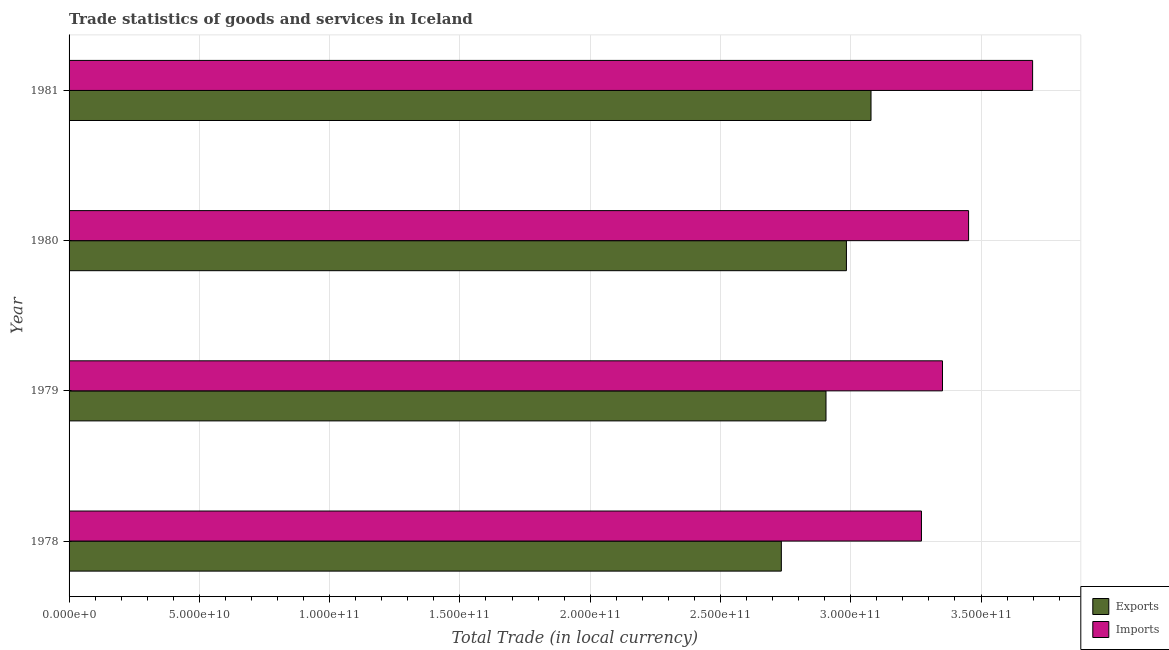How many different coloured bars are there?
Provide a short and direct response. 2. Are the number of bars per tick equal to the number of legend labels?
Provide a short and direct response. Yes. Are the number of bars on each tick of the Y-axis equal?
Keep it short and to the point. Yes. How many bars are there on the 4th tick from the top?
Give a very brief answer. 2. What is the label of the 4th group of bars from the top?
Your answer should be very brief. 1978. In how many cases, is the number of bars for a given year not equal to the number of legend labels?
Offer a very short reply. 0. What is the export of goods and services in 1981?
Provide a short and direct response. 3.08e+11. Across all years, what is the maximum export of goods and services?
Your response must be concise. 3.08e+11. Across all years, what is the minimum imports of goods and services?
Your answer should be compact. 3.27e+11. In which year was the imports of goods and services minimum?
Ensure brevity in your answer.  1978. What is the total imports of goods and services in the graph?
Offer a very short reply. 1.38e+12. What is the difference between the export of goods and services in 1978 and that in 1981?
Keep it short and to the point. -3.44e+1. What is the difference between the export of goods and services in 1978 and the imports of goods and services in 1979?
Your response must be concise. -6.18e+1. What is the average export of goods and services per year?
Keep it short and to the point. 2.92e+11. In the year 1980, what is the difference between the imports of goods and services and export of goods and services?
Your answer should be compact. 4.69e+1. In how many years, is the export of goods and services greater than 100000000000 LCU?
Ensure brevity in your answer.  4. What is the ratio of the export of goods and services in 1978 to that in 1979?
Make the answer very short. 0.94. Is the difference between the export of goods and services in 1979 and 1980 greater than the difference between the imports of goods and services in 1979 and 1980?
Offer a very short reply. Yes. What is the difference between the highest and the second highest imports of goods and services?
Provide a succinct answer. 2.46e+1. What is the difference between the highest and the lowest imports of goods and services?
Give a very brief answer. 4.27e+1. Is the sum of the export of goods and services in 1979 and 1980 greater than the maximum imports of goods and services across all years?
Ensure brevity in your answer.  Yes. What does the 2nd bar from the top in 1980 represents?
Your answer should be compact. Exports. What does the 2nd bar from the bottom in 1978 represents?
Your response must be concise. Imports. How many bars are there?
Your answer should be very brief. 8. Are all the bars in the graph horizontal?
Your response must be concise. Yes. How many years are there in the graph?
Offer a terse response. 4. Are the values on the major ticks of X-axis written in scientific E-notation?
Provide a succinct answer. Yes. Does the graph contain any zero values?
Make the answer very short. No. Does the graph contain grids?
Make the answer very short. Yes. Where does the legend appear in the graph?
Your answer should be very brief. Bottom right. How many legend labels are there?
Provide a succinct answer. 2. How are the legend labels stacked?
Make the answer very short. Vertical. What is the title of the graph?
Your answer should be very brief. Trade statistics of goods and services in Iceland. Does "Travel Items" appear as one of the legend labels in the graph?
Offer a terse response. No. What is the label or title of the X-axis?
Provide a succinct answer. Total Trade (in local currency). What is the Total Trade (in local currency) of Exports in 1978?
Make the answer very short. 2.73e+11. What is the Total Trade (in local currency) of Imports in 1978?
Your response must be concise. 3.27e+11. What is the Total Trade (in local currency) of Exports in 1979?
Provide a short and direct response. 2.91e+11. What is the Total Trade (in local currency) in Imports in 1979?
Ensure brevity in your answer.  3.35e+11. What is the Total Trade (in local currency) in Exports in 1980?
Keep it short and to the point. 2.98e+11. What is the Total Trade (in local currency) in Imports in 1980?
Offer a very short reply. 3.45e+11. What is the Total Trade (in local currency) of Exports in 1981?
Give a very brief answer. 3.08e+11. What is the Total Trade (in local currency) of Imports in 1981?
Provide a succinct answer. 3.70e+11. Across all years, what is the maximum Total Trade (in local currency) in Exports?
Offer a terse response. 3.08e+11. Across all years, what is the maximum Total Trade (in local currency) of Imports?
Offer a very short reply. 3.70e+11. Across all years, what is the minimum Total Trade (in local currency) of Exports?
Offer a terse response. 2.73e+11. Across all years, what is the minimum Total Trade (in local currency) in Imports?
Offer a terse response. 3.27e+11. What is the total Total Trade (in local currency) of Exports in the graph?
Your answer should be compact. 1.17e+12. What is the total Total Trade (in local currency) of Imports in the graph?
Your answer should be compact. 1.38e+12. What is the difference between the Total Trade (in local currency) of Exports in 1978 and that in 1979?
Give a very brief answer. -1.71e+1. What is the difference between the Total Trade (in local currency) of Imports in 1978 and that in 1979?
Give a very brief answer. -8.07e+09. What is the difference between the Total Trade (in local currency) in Exports in 1978 and that in 1980?
Offer a very short reply. -2.50e+1. What is the difference between the Total Trade (in local currency) in Imports in 1978 and that in 1980?
Provide a succinct answer. -1.81e+1. What is the difference between the Total Trade (in local currency) in Exports in 1978 and that in 1981?
Your response must be concise. -3.44e+1. What is the difference between the Total Trade (in local currency) in Imports in 1978 and that in 1981?
Keep it short and to the point. -4.27e+1. What is the difference between the Total Trade (in local currency) of Exports in 1979 and that in 1980?
Provide a succinct answer. -7.84e+09. What is the difference between the Total Trade (in local currency) in Imports in 1979 and that in 1980?
Offer a terse response. -1.00e+1. What is the difference between the Total Trade (in local currency) in Exports in 1979 and that in 1981?
Your response must be concise. -1.73e+1. What is the difference between the Total Trade (in local currency) in Imports in 1979 and that in 1981?
Your response must be concise. -3.46e+1. What is the difference between the Total Trade (in local currency) in Exports in 1980 and that in 1981?
Make the answer very short. -9.44e+09. What is the difference between the Total Trade (in local currency) of Imports in 1980 and that in 1981?
Make the answer very short. -2.46e+1. What is the difference between the Total Trade (in local currency) in Exports in 1978 and the Total Trade (in local currency) in Imports in 1979?
Make the answer very short. -6.18e+1. What is the difference between the Total Trade (in local currency) in Exports in 1978 and the Total Trade (in local currency) in Imports in 1980?
Provide a succinct answer. -7.19e+1. What is the difference between the Total Trade (in local currency) in Exports in 1978 and the Total Trade (in local currency) in Imports in 1981?
Provide a short and direct response. -9.64e+1. What is the difference between the Total Trade (in local currency) in Exports in 1979 and the Total Trade (in local currency) in Imports in 1980?
Your response must be concise. -5.47e+1. What is the difference between the Total Trade (in local currency) in Exports in 1979 and the Total Trade (in local currency) in Imports in 1981?
Offer a very short reply. -7.93e+1. What is the difference between the Total Trade (in local currency) in Exports in 1980 and the Total Trade (in local currency) in Imports in 1981?
Offer a very short reply. -7.15e+1. What is the average Total Trade (in local currency) of Exports per year?
Your answer should be compact. 2.92e+11. What is the average Total Trade (in local currency) in Imports per year?
Provide a succinct answer. 3.44e+11. In the year 1978, what is the difference between the Total Trade (in local currency) in Exports and Total Trade (in local currency) in Imports?
Provide a short and direct response. -5.38e+1. In the year 1979, what is the difference between the Total Trade (in local currency) in Exports and Total Trade (in local currency) in Imports?
Provide a short and direct response. -4.47e+1. In the year 1980, what is the difference between the Total Trade (in local currency) of Exports and Total Trade (in local currency) of Imports?
Your response must be concise. -4.69e+1. In the year 1981, what is the difference between the Total Trade (in local currency) in Exports and Total Trade (in local currency) in Imports?
Your response must be concise. -6.20e+1. What is the ratio of the Total Trade (in local currency) in Exports in 1978 to that in 1979?
Make the answer very short. 0.94. What is the ratio of the Total Trade (in local currency) of Imports in 1978 to that in 1979?
Offer a terse response. 0.98. What is the ratio of the Total Trade (in local currency) of Exports in 1978 to that in 1980?
Your answer should be very brief. 0.92. What is the ratio of the Total Trade (in local currency) of Imports in 1978 to that in 1980?
Ensure brevity in your answer.  0.95. What is the ratio of the Total Trade (in local currency) of Exports in 1978 to that in 1981?
Offer a very short reply. 0.89. What is the ratio of the Total Trade (in local currency) in Imports in 1978 to that in 1981?
Ensure brevity in your answer.  0.88. What is the ratio of the Total Trade (in local currency) in Exports in 1979 to that in 1980?
Provide a succinct answer. 0.97. What is the ratio of the Total Trade (in local currency) of Exports in 1979 to that in 1981?
Provide a short and direct response. 0.94. What is the ratio of the Total Trade (in local currency) of Imports in 1979 to that in 1981?
Provide a succinct answer. 0.91. What is the ratio of the Total Trade (in local currency) in Exports in 1980 to that in 1981?
Ensure brevity in your answer.  0.97. What is the ratio of the Total Trade (in local currency) in Imports in 1980 to that in 1981?
Your answer should be very brief. 0.93. What is the difference between the highest and the second highest Total Trade (in local currency) in Exports?
Make the answer very short. 9.44e+09. What is the difference between the highest and the second highest Total Trade (in local currency) of Imports?
Make the answer very short. 2.46e+1. What is the difference between the highest and the lowest Total Trade (in local currency) of Exports?
Your response must be concise. 3.44e+1. What is the difference between the highest and the lowest Total Trade (in local currency) of Imports?
Ensure brevity in your answer.  4.27e+1. 